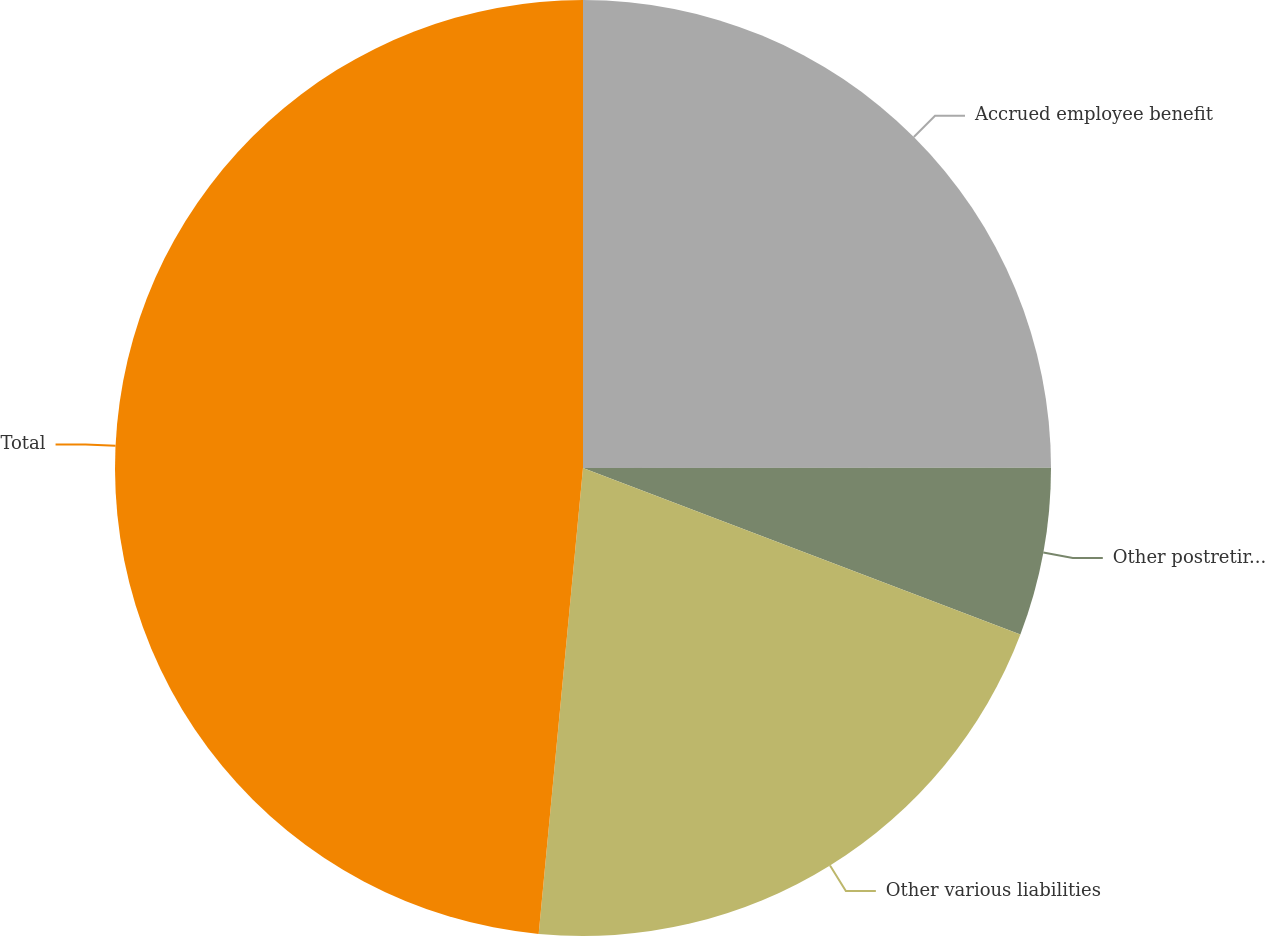<chart> <loc_0><loc_0><loc_500><loc_500><pie_chart><fcel>Accrued employee benefit<fcel>Other postretirement liability<fcel>Other various liabilities<fcel>Total<nl><fcel>24.99%<fcel>5.8%<fcel>20.72%<fcel>48.49%<nl></chart> 